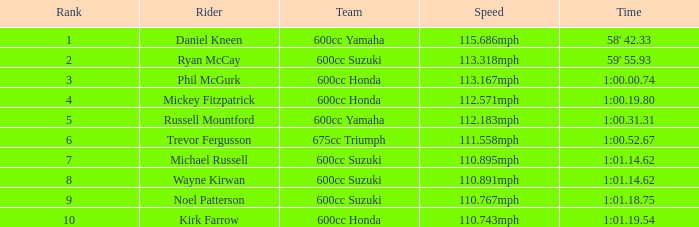What time has phil mcgurk as the rider? 1:00.00.74. 